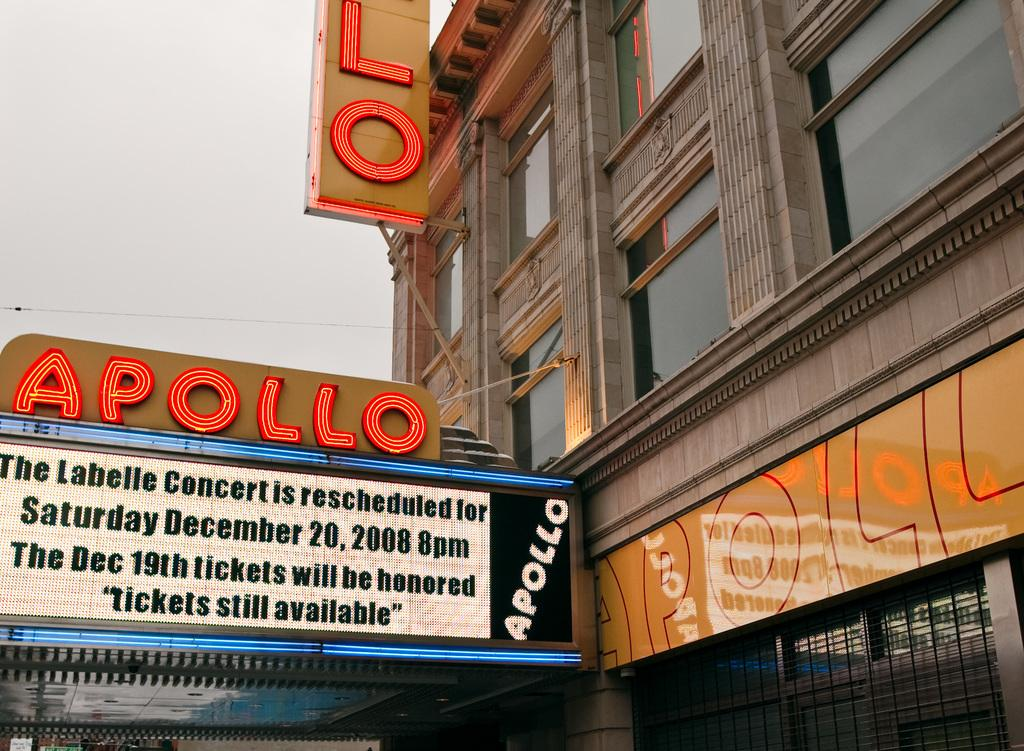What type of structure is present in the image? There is a building in the image. What feature can be observed on the building? The building has glass windows. What else can be seen in the image besides the building? There are boards in the image, and something is written on them. What is the color of the sky in the image? The sky appears to be white in color. Where is the kettle located in the image? There is no kettle present in the image. What type of cloth is draped over the boards in the image? There is no cloth draped over the boards in the image; the boards have writing on them. 